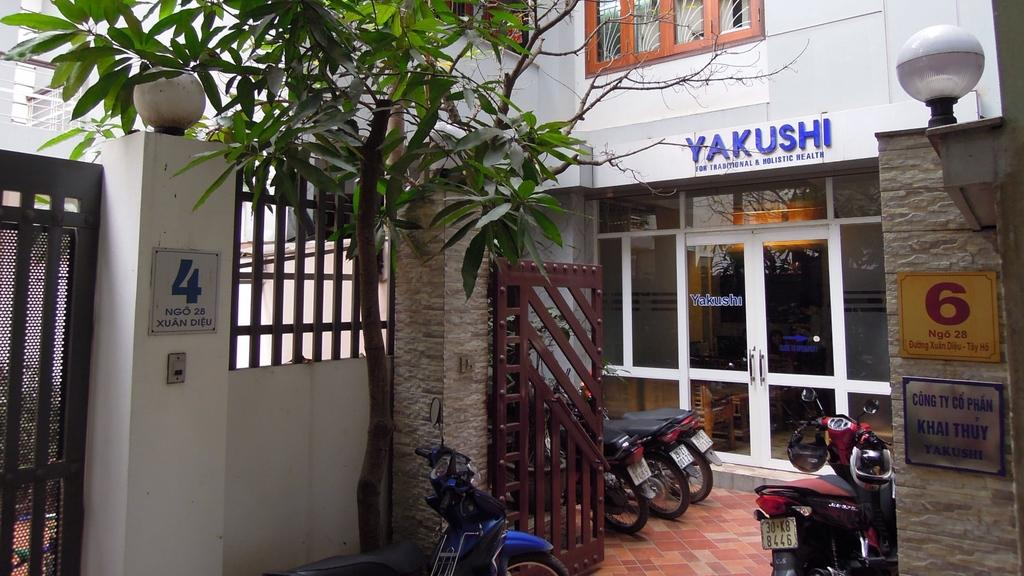What can be seen parked in front of the building in the image? There are bikes parked in front of a building in the image. What is attached to the wall near the bikes? There are lights on the wall. What architectural feature is present on the side of the wall? There is a gate on the side of the wall. What type of vegetation is in the middle of the image? There is a tree in the middle of the image, in front of a bike. What type of breakfast is being served on the bike in the image? There is no breakfast present in the image; it features bikes parked in front of a building. Can you see any icicles hanging from the tree in the image? There are no icicles present in the image; it is a tree with no visible ice or icicles. 